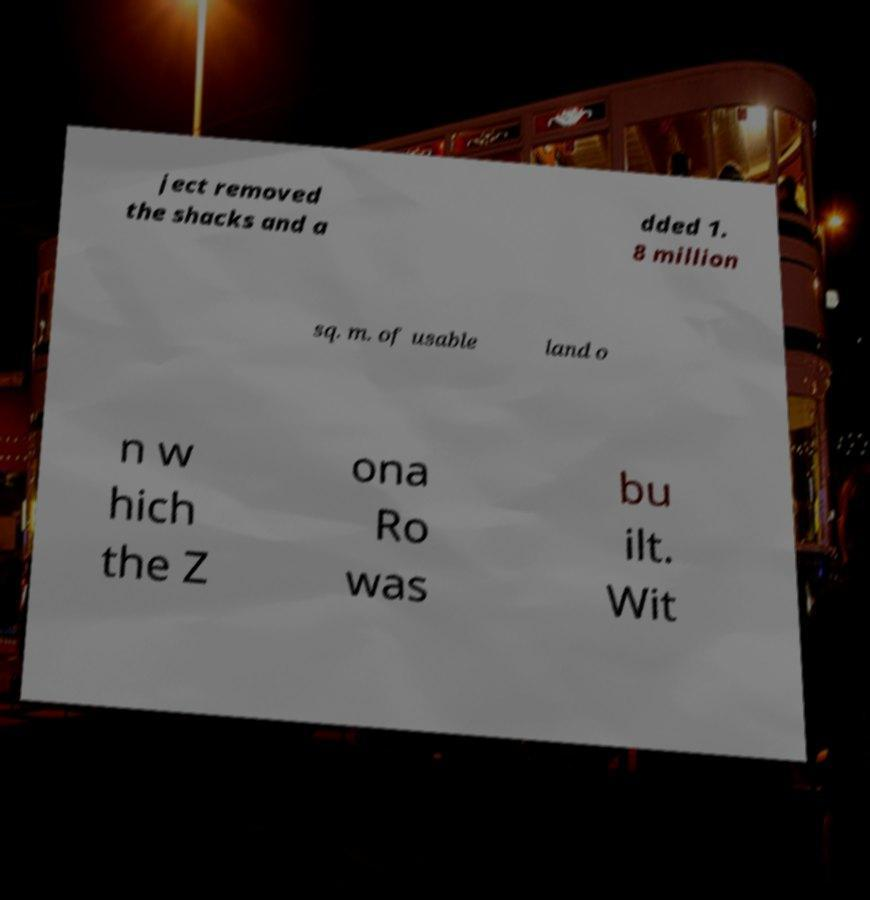Please read and relay the text visible in this image. What does it say? ject removed the shacks and a dded 1. 8 million sq. m. of usable land o n w hich the Z ona Ro was bu ilt. Wit 